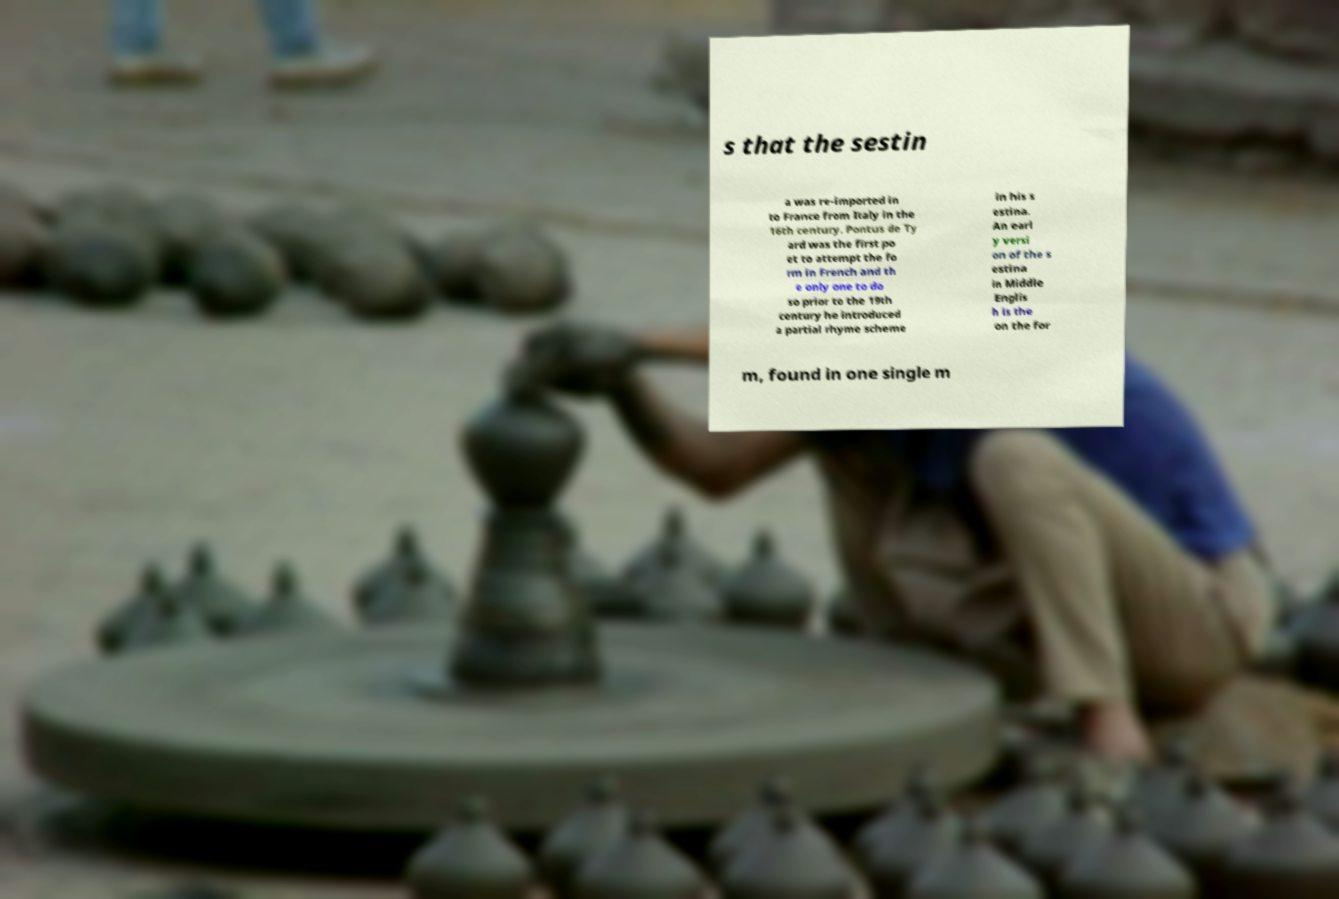There's text embedded in this image that I need extracted. Can you transcribe it verbatim? s that the sestin a was re-imported in to France from Italy in the 16th century. Pontus de Ty ard was the first po et to attempt the fo rm in French and th e only one to do so prior to the 19th century he introduced a partial rhyme scheme in his s estina. An earl y versi on of the s estina in Middle Englis h is the on the for m, found in one single m 